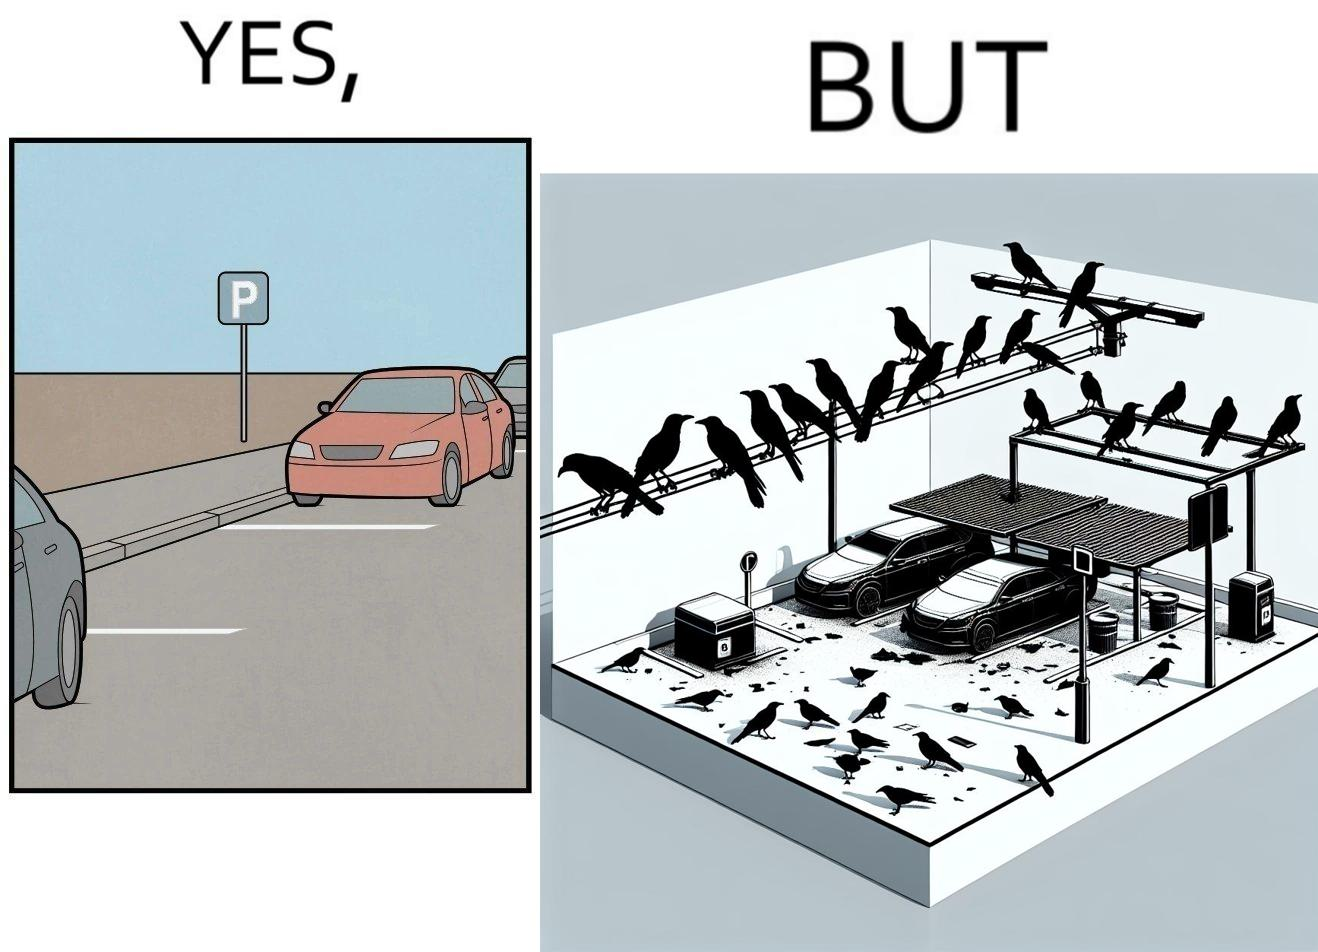Is there satirical content in this image? Yes, this image is satirical. 